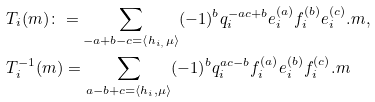Convert formula to latex. <formula><loc_0><loc_0><loc_500><loc_500>& T _ { i } ( m ) \colon = \sum _ { - a + b - c = \langle h _ { i , } \mu \rangle } ( - 1 ) ^ { b } q _ { i } ^ { - a c + b } e _ { i } ^ { ( a ) } f _ { i } ^ { ( b ) } e _ { i } ^ { ( c ) } . m , \\ & T _ { i } ^ { - 1 } ( m ) = \sum _ { a - b + c = \langle h _ { i } , \mu \rangle } ( - 1 ) ^ { b } q _ { i } ^ { a c - b } f _ { i } ^ { ( a ) } e _ { i } ^ { ( b ) } f _ { i } ^ { ( c ) } . m</formula> 